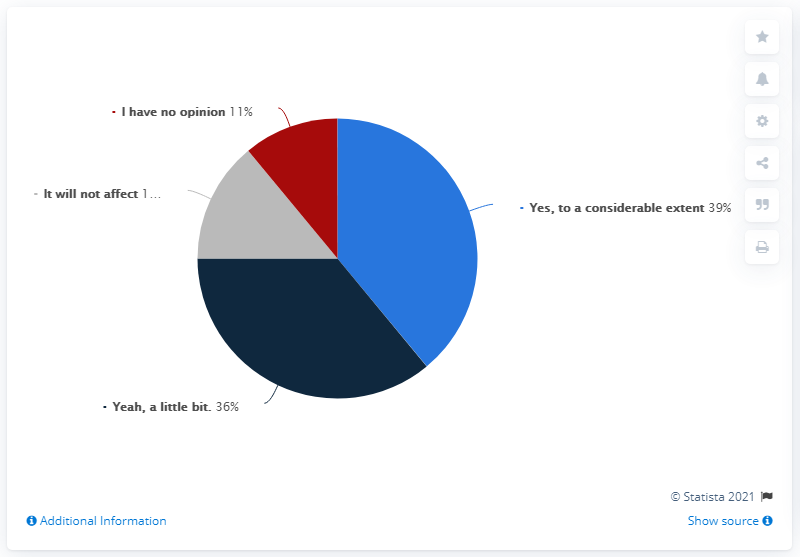Point out several critical features in this image. The largest slice of the pie has a value of 39%, and it is colored blue. 